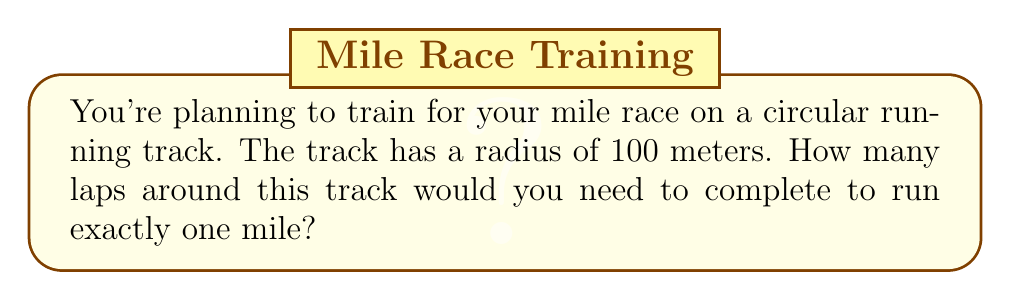Give your solution to this math problem. Let's approach this step-by-step:

1) First, we need to calculate the circumference of the circular track.
   The formula for circumference is $C = 2\pi r$, where $r$ is the radius.

   $C = 2 \pi (100)$
   $C = 200\pi$ meters

2) Now, we need to convert one mile to meters.
   1 mile = 1609.34 meters

3) To find the number of laps, we divide the length of one mile by the circumference of the track:

   $\text{Number of laps} = \frac{1609.34}{200\pi}$

4) Let's calculate this:

   $$\begin{align}
   \text{Number of laps} &= \frac{1609.34}{200\pi} \\
   &\approx \frac{1609.34}{628.32} \\
   &\approx 2.56
   \end{align}$$

5) Since we can't run a partial lap, we need to round up to the nearest whole number.

Therefore, you would need to complete 3 laps to run at least one mile.

[asy]
unitsize(1cm);
draw(circle((0,0),3));
draw((0,0)--(3,0), arrow=Arrow(TeXHead));
label("100m", (1.5,0.3));
label("Start/Finish", (-3.5,0));
[/asy]
Answer: 3 laps 